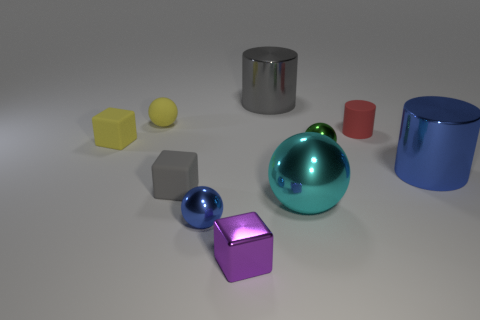What is the color of the tiny block in front of the small rubber cube in front of the blue object that is to the right of the big cyan shiny ball?
Provide a short and direct response. Purple. Are there any large yellow rubber things that have the same shape as the big gray metallic object?
Your response must be concise. No. Is the number of tiny yellow objects behind the small red cylinder the same as the number of small green shiny things that are in front of the big blue object?
Provide a short and direct response. No. There is a big thing right of the red matte cylinder; is it the same shape as the large cyan thing?
Keep it short and to the point. No. Do the gray metallic object and the small gray object have the same shape?
Your response must be concise. No. How many matte objects are either big gray cylinders or big purple cubes?
Your response must be concise. 0. There is a block that is the same color as the matte sphere; what is its material?
Your answer should be compact. Rubber. Does the metal block have the same size as the rubber ball?
Keep it short and to the point. Yes. How many things are either big blue metallic blocks or tiny things behind the gray matte block?
Provide a short and direct response. 4. There is a purple object that is the same size as the red cylinder; what material is it?
Your answer should be compact. Metal. 